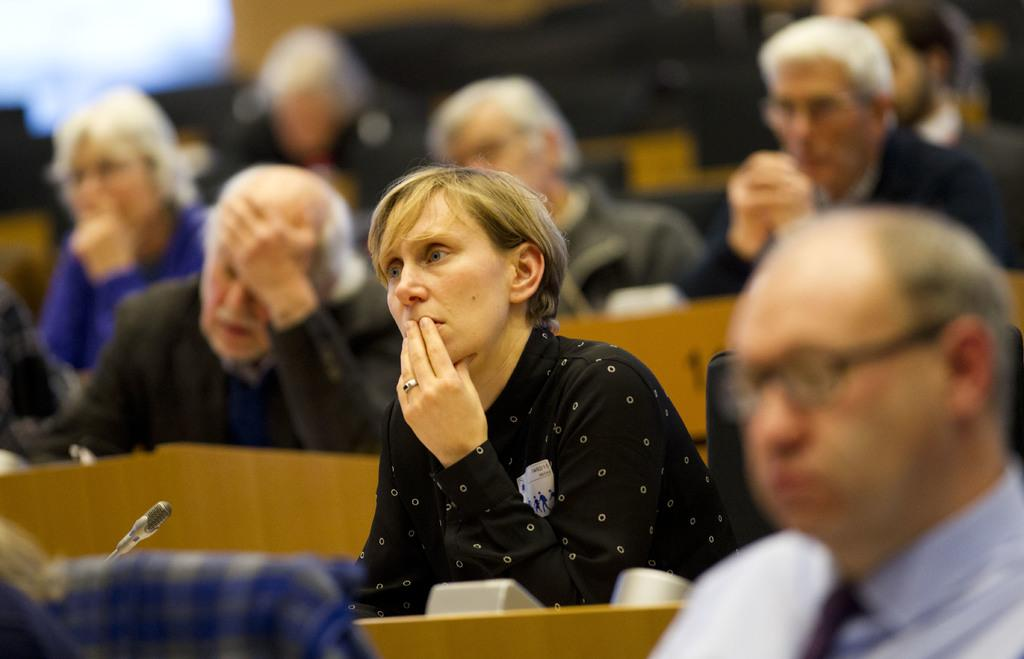What are the people in the image doing? The people in the image are sitting. What objects are in front of the people? There are microphones in front of the people. Can you describe the background of the image? The background of the image is blurred. What type of scissors can be seen in the image? There are no scissors present in the image. 